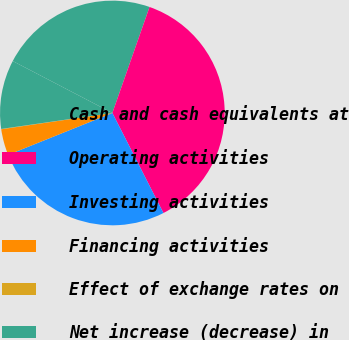Convert chart to OTSL. <chart><loc_0><loc_0><loc_500><loc_500><pie_chart><fcel>Cash and cash equivalents at<fcel>Operating activities<fcel>Investing activities<fcel>Financing activities<fcel>Effect of exchange rates on<fcel>Net increase (decrease) in<nl><fcel>22.72%<fcel>37.12%<fcel>26.43%<fcel>3.76%<fcel>0.05%<fcel>9.92%<nl></chart> 